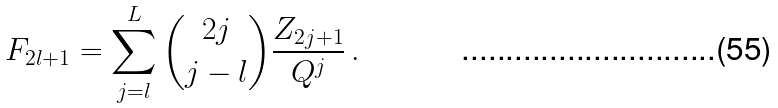<formula> <loc_0><loc_0><loc_500><loc_500>F _ { 2 l + 1 } = \sum _ { j = l } ^ { L } { 2 j \choose j - l } \frac { Z _ { 2 j + 1 } } { Q ^ { j } } \, .</formula> 